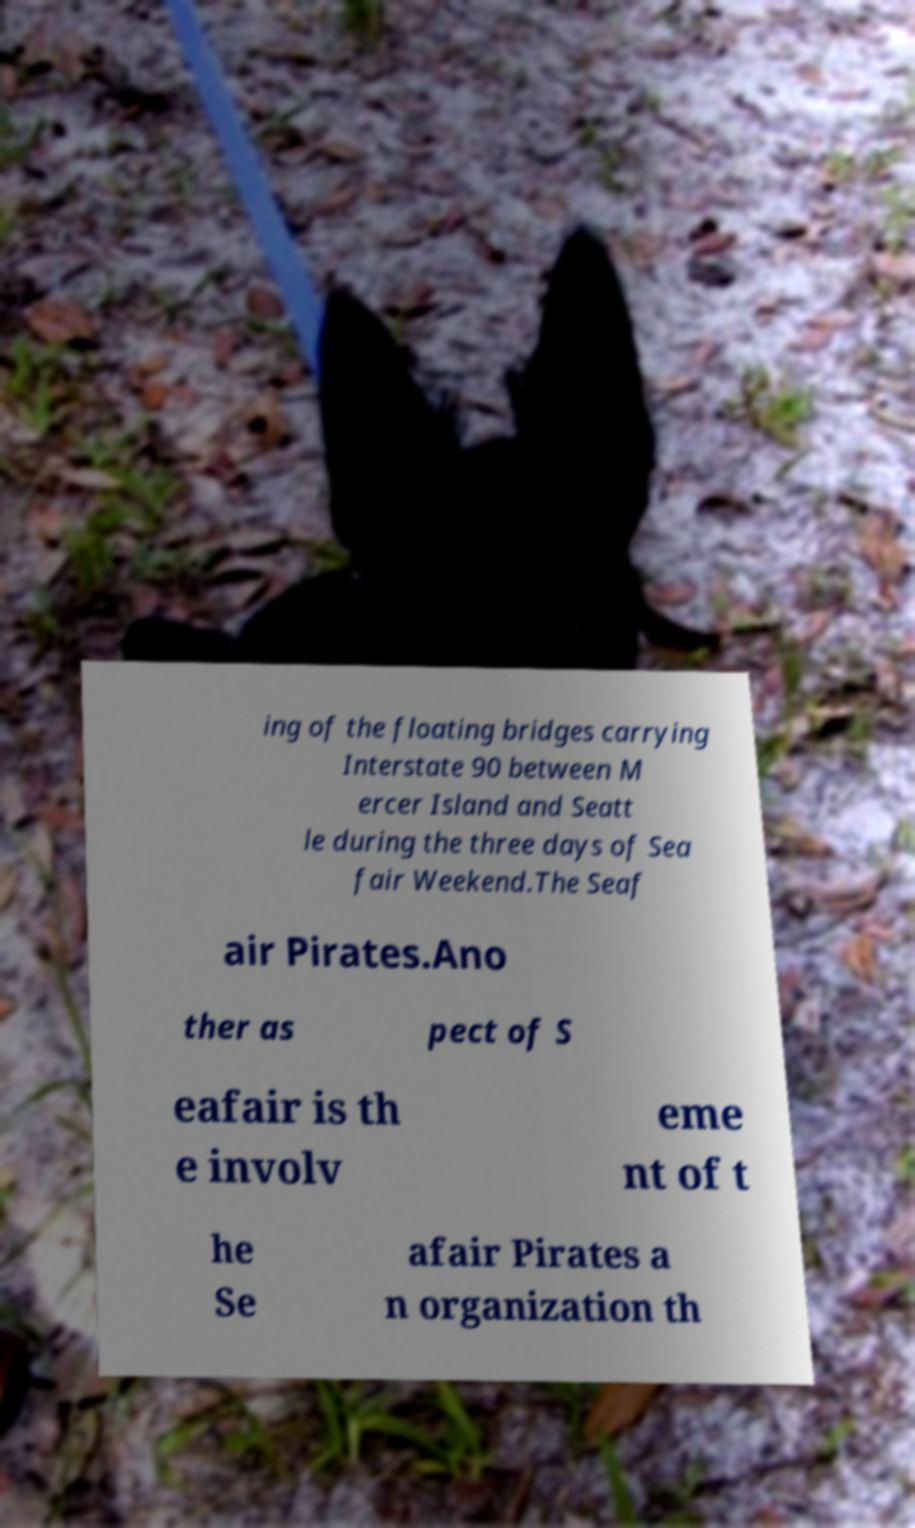For documentation purposes, I need the text within this image transcribed. Could you provide that? ing of the floating bridges carrying Interstate 90 between M ercer Island and Seatt le during the three days of Sea fair Weekend.The Seaf air Pirates.Ano ther as pect of S eafair is th e involv eme nt of t he Se afair Pirates a n organization th 